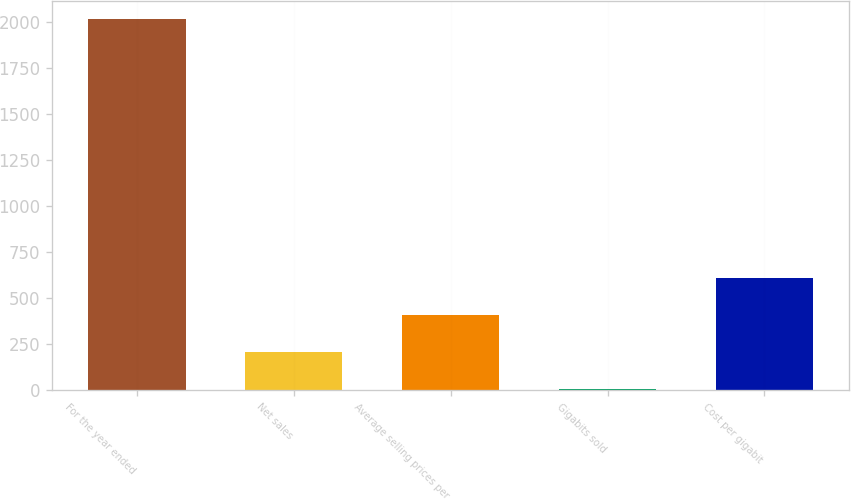Convert chart to OTSL. <chart><loc_0><loc_0><loc_500><loc_500><bar_chart><fcel>For the year ended<fcel>Net sales<fcel>Average selling prices per<fcel>Gigabits sold<fcel>Cost per gigabit<nl><fcel>2015<fcel>205.1<fcel>406.2<fcel>4<fcel>607.3<nl></chart> 